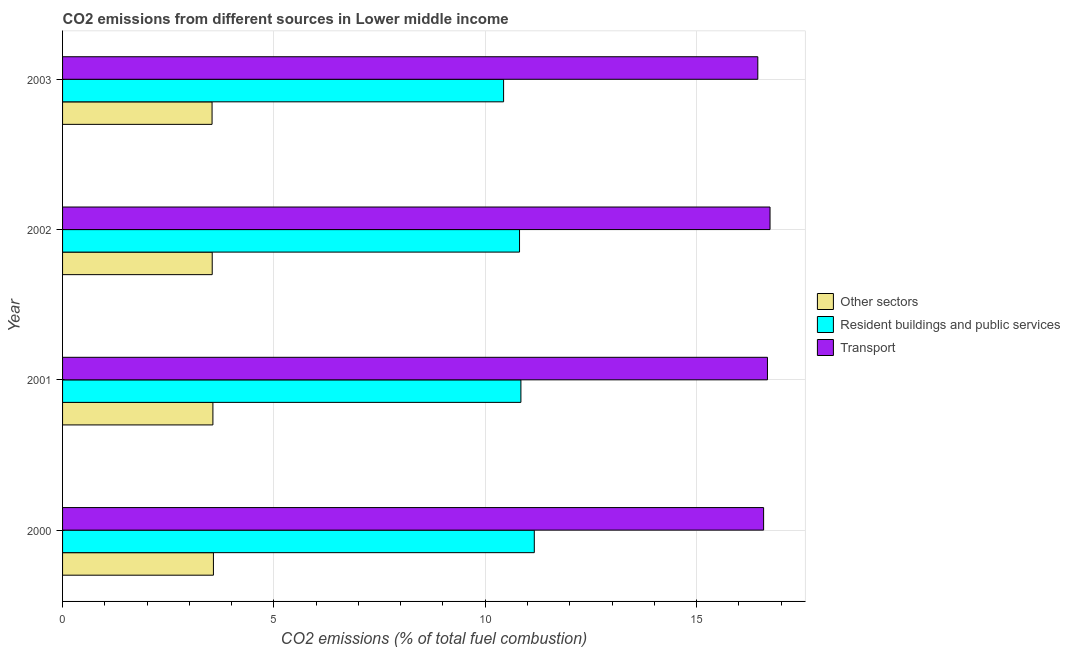How many different coloured bars are there?
Your answer should be compact. 3. How many groups of bars are there?
Give a very brief answer. 4. Are the number of bars on each tick of the Y-axis equal?
Provide a short and direct response. Yes. What is the label of the 4th group of bars from the top?
Make the answer very short. 2000. What is the percentage of co2 emissions from transport in 2000?
Provide a short and direct response. 16.59. Across all years, what is the maximum percentage of co2 emissions from other sectors?
Offer a terse response. 3.57. Across all years, what is the minimum percentage of co2 emissions from transport?
Offer a terse response. 16.45. In which year was the percentage of co2 emissions from transport maximum?
Your answer should be very brief. 2002. In which year was the percentage of co2 emissions from transport minimum?
Your answer should be very brief. 2003. What is the total percentage of co2 emissions from transport in the graph?
Offer a very short reply. 66.45. What is the difference between the percentage of co2 emissions from transport in 2001 and that in 2003?
Make the answer very short. 0.23. What is the difference between the percentage of co2 emissions from other sectors in 2001 and the percentage of co2 emissions from resident buildings and public services in 2003?
Your response must be concise. -6.88. What is the average percentage of co2 emissions from transport per year?
Ensure brevity in your answer.  16.61. In the year 2002, what is the difference between the percentage of co2 emissions from resident buildings and public services and percentage of co2 emissions from other sectors?
Provide a succinct answer. 7.27. What is the ratio of the percentage of co2 emissions from resident buildings and public services in 2001 to that in 2003?
Keep it short and to the point. 1.04. Is the difference between the percentage of co2 emissions from other sectors in 2001 and 2003 greater than the difference between the percentage of co2 emissions from transport in 2001 and 2003?
Offer a terse response. No. What is the difference between the highest and the second highest percentage of co2 emissions from other sectors?
Your answer should be very brief. 0.01. What is the difference between the highest and the lowest percentage of co2 emissions from other sectors?
Provide a short and direct response. 0.03. In how many years, is the percentage of co2 emissions from resident buildings and public services greater than the average percentage of co2 emissions from resident buildings and public services taken over all years?
Your response must be concise. 2. Is the sum of the percentage of co2 emissions from other sectors in 2000 and 2002 greater than the maximum percentage of co2 emissions from transport across all years?
Give a very brief answer. No. What does the 1st bar from the top in 2000 represents?
Your response must be concise. Transport. What does the 1st bar from the bottom in 2002 represents?
Your answer should be compact. Other sectors. How many bars are there?
Give a very brief answer. 12. Are all the bars in the graph horizontal?
Provide a short and direct response. Yes. Are the values on the major ticks of X-axis written in scientific E-notation?
Offer a terse response. No. Does the graph contain grids?
Offer a very short reply. Yes. What is the title of the graph?
Offer a terse response. CO2 emissions from different sources in Lower middle income. What is the label or title of the X-axis?
Your answer should be compact. CO2 emissions (% of total fuel combustion). What is the CO2 emissions (% of total fuel combustion) of Other sectors in 2000?
Ensure brevity in your answer.  3.57. What is the CO2 emissions (% of total fuel combustion) of Resident buildings and public services in 2000?
Your response must be concise. 11.16. What is the CO2 emissions (% of total fuel combustion) of Transport in 2000?
Make the answer very short. 16.59. What is the CO2 emissions (% of total fuel combustion) of Other sectors in 2001?
Offer a very short reply. 3.56. What is the CO2 emissions (% of total fuel combustion) of Resident buildings and public services in 2001?
Offer a very short reply. 10.84. What is the CO2 emissions (% of total fuel combustion) in Transport in 2001?
Your response must be concise. 16.68. What is the CO2 emissions (% of total fuel combustion) of Other sectors in 2002?
Provide a short and direct response. 3.54. What is the CO2 emissions (% of total fuel combustion) in Resident buildings and public services in 2002?
Ensure brevity in your answer.  10.81. What is the CO2 emissions (% of total fuel combustion) in Transport in 2002?
Make the answer very short. 16.74. What is the CO2 emissions (% of total fuel combustion) of Other sectors in 2003?
Your answer should be compact. 3.54. What is the CO2 emissions (% of total fuel combustion) in Resident buildings and public services in 2003?
Ensure brevity in your answer.  10.43. What is the CO2 emissions (% of total fuel combustion) in Transport in 2003?
Your answer should be very brief. 16.45. Across all years, what is the maximum CO2 emissions (% of total fuel combustion) in Other sectors?
Your answer should be very brief. 3.57. Across all years, what is the maximum CO2 emissions (% of total fuel combustion) of Resident buildings and public services?
Provide a succinct answer. 11.16. Across all years, what is the maximum CO2 emissions (% of total fuel combustion) in Transport?
Make the answer very short. 16.74. Across all years, what is the minimum CO2 emissions (% of total fuel combustion) in Other sectors?
Your answer should be compact. 3.54. Across all years, what is the minimum CO2 emissions (% of total fuel combustion) in Resident buildings and public services?
Offer a very short reply. 10.43. Across all years, what is the minimum CO2 emissions (% of total fuel combustion) of Transport?
Provide a short and direct response. 16.45. What is the total CO2 emissions (% of total fuel combustion) of Other sectors in the graph?
Your answer should be very brief. 14.2. What is the total CO2 emissions (% of total fuel combustion) in Resident buildings and public services in the graph?
Offer a terse response. 43.25. What is the total CO2 emissions (% of total fuel combustion) in Transport in the graph?
Your answer should be compact. 66.45. What is the difference between the CO2 emissions (% of total fuel combustion) in Other sectors in 2000 and that in 2001?
Your answer should be very brief. 0.01. What is the difference between the CO2 emissions (% of total fuel combustion) of Resident buildings and public services in 2000 and that in 2001?
Provide a short and direct response. 0.32. What is the difference between the CO2 emissions (% of total fuel combustion) in Transport in 2000 and that in 2001?
Give a very brief answer. -0.09. What is the difference between the CO2 emissions (% of total fuel combustion) of Other sectors in 2000 and that in 2002?
Offer a very short reply. 0.03. What is the difference between the CO2 emissions (% of total fuel combustion) in Resident buildings and public services in 2000 and that in 2002?
Provide a short and direct response. 0.35. What is the difference between the CO2 emissions (% of total fuel combustion) in Transport in 2000 and that in 2002?
Provide a succinct answer. -0.15. What is the difference between the CO2 emissions (% of total fuel combustion) in Other sectors in 2000 and that in 2003?
Keep it short and to the point. 0.03. What is the difference between the CO2 emissions (% of total fuel combustion) of Resident buildings and public services in 2000 and that in 2003?
Give a very brief answer. 0.73. What is the difference between the CO2 emissions (% of total fuel combustion) in Transport in 2000 and that in 2003?
Ensure brevity in your answer.  0.14. What is the difference between the CO2 emissions (% of total fuel combustion) in Other sectors in 2001 and that in 2002?
Make the answer very short. 0.02. What is the difference between the CO2 emissions (% of total fuel combustion) in Resident buildings and public services in 2001 and that in 2002?
Provide a short and direct response. 0.03. What is the difference between the CO2 emissions (% of total fuel combustion) of Transport in 2001 and that in 2002?
Keep it short and to the point. -0.06. What is the difference between the CO2 emissions (% of total fuel combustion) of Other sectors in 2001 and that in 2003?
Make the answer very short. 0.02. What is the difference between the CO2 emissions (% of total fuel combustion) of Resident buildings and public services in 2001 and that in 2003?
Your answer should be compact. 0.41. What is the difference between the CO2 emissions (% of total fuel combustion) of Transport in 2001 and that in 2003?
Offer a terse response. 0.23. What is the difference between the CO2 emissions (% of total fuel combustion) in Other sectors in 2002 and that in 2003?
Make the answer very short. 0. What is the difference between the CO2 emissions (% of total fuel combustion) of Resident buildings and public services in 2002 and that in 2003?
Your answer should be compact. 0.38. What is the difference between the CO2 emissions (% of total fuel combustion) in Transport in 2002 and that in 2003?
Give a very brief answer. 0.29. What is the difference between the CO2 emissions (% of total fuel combustion) of Other sectors in 2000 and the CO2 emissions (% of total fuel combustion) of Resident buildings and public services in 2001?
Make the answer very short. -7.27. What is the difference between the CO2 emissions (% of total fuel combustion) in Other sectors in 2000 and the CO2 emissions (% of total fuel combustion) in Transport in 2001?
Provide a succinct answer. -13.11. What is the difference between the CO2 emissions (% of total fuel combustion) of Resident buildings and public services in 2000 and the CO2 emissions (% of total fuel combustion) of Transport in 2001?
Make the answer very short. -5.52. What is the difference between the CO2 emissions (% of total fuel combustion) in Other sectors in 2000 and the CO2 emissions (% of total fuel combustion) in Resident buildings and public services in 2002?
Keep it short and to the point. -7.24. What is the difference between the CO2 emissions (% of total fuel combustion) in Other sectors in 2000 and the CO2 emissions (% of total fuel combustion) in Transport in 2002?
Offer a terse response. -13.17. What is the difference between the CO2 emissions (% of total fuel combustion) in Resident buildings and public services in 2000 and the CO2 emissions (% of total fuel combustion) in Transport in 2002?
Give a very brief answer. -5.58. What is the difference between the CO2 emissions (% of total fuel combustion) of Other sectors in 2000 and the CO2 emissions (% of total fuel combustion) of Resident buildings and public services in 2003?
Your response must be concise. -6.87. What is the difference between the CO2 emissions (% of total fuel combustion) of Other sectors in 2000 and the CO2 emissions (% of total fuel combustion) of Transport in 2003?
Make the answer very short. -12.88. What is the difference between the CO2 emissions (% of total fuel combustion) of Resident buildings and public services in 2000 and the CO2 emissions (% of total fuel combustion) of Transport in 2003?
Offer a very short reply. -5.29. What is the difference between the CO2 emissions (% of total fuel combustion) in Other sectors in 2001 and the CO2 emissions (% of total fuel combustion) in Resident buildings and public services in 2002?
Make the answer very short. -7.25. What is the difference between the CO2 emissions (% of total fuel combustion) in Other sectors in 2001 and the CO2 emissions (% of total fuel combustion) in Transport in 2002?
Provide a succinct answer. -13.18. What is the difference between the CO2 emissions (% of total fuel combustion) in Resident buildings and public services in 2001 and the CO2 emissions (% of total fuel combustion) in Transport in 2002?
Make the answer very short. -5.89. What is the difference between the CO2 emissions (% of total fuel combustion) of Other sectors in 2001 and the CO2 emissions (% of total fuel combustion) of Resident buildings and public services in 2003?
Offer a very short reply. -6.88. What is the difference between the CO2 emissions (% of total fuel combustion) in Other sectors in 2001 and the CO2 emissions (% of total fuel combustion) in Transport in 2003?
Offer a terse response. -12.89. What is the difference between the CO2 emissions (% of total fuel combustion) of Resident buildings and public services in 2001 and the CO2 emissions (% of total fuel combustion) of Transport in 2003?
Offer a very short reply. -5.61. What is the difference between the CO2 emissions (% of total fuel combustion) of Other sectors in 2002 and the CO2 emissions (% of total fuel combustion) of Resident buildings and public services in 2003?
Offer a very short reply. -6.89. What is the difference between the CO2 emissions (% of total fuel combustion) in Other sectors in 2002 and the CO2 emissions (% of total fuel combustion) in Transport in 2003?
Your response must be concise. -12.91. What is the difference between the CO2 emissions (% of total fuel combustion) of Resident buildings and public services in 2002 and the CO2 emissions (% of total fuel combustion) of Transport in 2003?
Your answer should be compact. -5.64. What is the average CO2 emissions (% of total fuel combustion) in Other sectors per year?
Offer a very short reply. 3.55. What is the average CO2 emissions (% of total fuel combustion) in Resident buildings and public services per year?
Offer a terse response. 10.81. What is the average CO2 emissions (% of total fuel combustion) in Transport per year?
Your answer should be compact. 16.61. In the year 2000, what is the difference between the CO2 emissions (% of total fuel combustion) in Other sectors and CO2 emissions (% of total fuel combustion) in Resident buildings and public services?
Your answer should be very brief. -7.59. In the year 2000, what is the difference between the CO2 emissions (% of total fuel combustion) of Other sectors and CO2 emissions (% of total fuel combustion) of Transport?
Your answer should be compact. -13.02. In the year 2000, what is the difference between the CO2 emissions (% of total fuel combustion) in Resident buildings and public services and CO2 emissions (% of total fuel combustion) in Transport?
Ensure brevity in your answer.  -5.43. In the year 2001, what is the difference between the CO2 emissions (% of total fuel combustion) of Other sectors and CO2 emissions (% of total fuel combustion) of Resident buildings and public services?
Your answer should be very brief. -7.29. In the year 2001, what is the difference between the CO2 emissions (% of total fuel combustion) in Other sectors and CO2 emissions (% of total fuel combustion) in Transport?
Provide a succinct answer. -13.12. In the year 2001, what is the difference between the CO2 emissions (% of total fuel combustion) in Resident buildings and public services and CO2 emissions (% of total fuel combustion) in Transport?
Your answer should be very brief. -5.83. In the year 2002, what is the difference between the CO2 emissions (% of total fuel combustion) in Other sectors and CO2 emissions (% of total fuel combustion) in Resident buildings and public services?
Give a very brief answer. -7.27. In the year 2002, what is the difference between the CO2 emissions (% of total fuel combustion) of Other sectors and CO2 emissions (% of total fuel combustion) of Transport?
Provide a short and direct response. -13.2. In the year 2002, what is the difference between the CO2 emissions (% of total fuel combustion) in Resident buildings and public services and CO2 emissions (% of total fuel combustion) in Transport?
Provide a succinct answer. -5.93. In the year 2003, what is the difference between the CO2 emissions (% of total fuel combustion) in Other sectors and CO2 emissions (% of total fuel combustion) in Resident buildings and public services?
Give a very brief answer. -6.9. In the year 2003, what is the difference between the CO2 emissions (% of total fuel combustion) in Other sectors and CO2 emissions (% of total fuel combustion) in Transport?
Your response must be concise. -12.91. In the year 2003, what is the difference between the CO2 emissions (% of total fuel combustion) of Resident buildings and public services and CO2 emissions (% of total fuel combustion) of Transport?
Your response must be concise. -6.01. What is the ratio of the CO2 emissions (% of total fuel combustion) of Other sectors in 2000 to that in 2001?
Give a very brief answer. 1. What is the ratio of the CO2 emissions (% of total fuel combustion) of Resident buildings and public services in 2000 to that in 2001?
Your response must be concise. 1.03. What is the ratio of the CO2 emissions (% of total fuel combustion) of Resident buildings and public services in 2000 to that in 2002?
Your answer should be compact. 1.03. What is the ratio of the CO2 emissions (% of total fuel combustion) in Transport in 2000 to that in 2002?
Give a very brief answer. 0.99. What is the ratio of the CO2 emissions (% of total fuel combustion) of Other sectors in 2000 to that in 2003?
Make the answer very short. 1.01. What is the ratio of the CO2 emissions (% of total fuel combustion) in Resident buildings and public services in 2000 to that in 2003?
Your response must be concise. 1.07. What is the ratio of the CO2 emissions (% of total fuel combustion) of Transport in 2000 to that in 2003?
Offer a very short reply. 1.01. What is the ratio of the CO2 emissions (% of total fuel combustion) in Resident buildings and public services in 2001 to that in 2002?
Provide a succinct answer. 1. What is the ratio of the CO2 emissions (% of total fuel combustion) in Transport in 2001 to that in 2002?
Keep it short and to the point. 1. What is the ratio of the CO2 emissions (% of total fuel combustion) of Other sectors in 2001 to that in 2003?
Give a very brief answer. 1.01. What is the ratio of the CO2 emissions (% of total fuel combustion) of Resident buildings and public services in 2001 to that in 2003?
Keep it short and to the point. 1.04. What is the ratio of the CO2 emissions (% of total fuel combustion) in Transport in 2001 to that in 2003?
Give a very brief answer. 1.01. What is the ratio of the CO2 emissions (% of total fuel combustion) in Other sectors in 2002 to that in 2003?
Ensure brevity in your answer.  1. What is the ratio of the CO2 emissions (% of total fuel combustion) of Resident buildings and public services in 2002 to that in 2003?
Make the answer very short. 1.04. What is the ratio of the CO2 emissions (% of total fuel combustion) of Transport in 2002 to that in 2003?
Give a very brief answer. 1.02. What is the difference between the highest and the second highest CO2 emissions (% of total fuel combustion) of Other sectors?
Give a very brief answer. 0.01. What is the difference between the highest and the second highest CO2 emissions (% of total fuel combustion) in Resident buildings and public services?
Make the answer very short. 0.32. What is the difference between the highest and the second highest CO2 emissions (% of total fuel combustion) in Transport?
Offer a very short reply. 0.06. What is the difference between the highest and the lowest CO2 emissions (% of total fuel combustion) in Other sectors?
Provide a succinct answer. 0.03. What is the difference between the highest and the lowest CO2 emissions (% of total fuel combustion) in Resident buildings and public services?
Your answer should be very brief. 0.73. What is the difference between the highest and the lowest CO2 emissions (% of total fuel combustion) in Transport?
Provide a short and direct response. 0.29. 